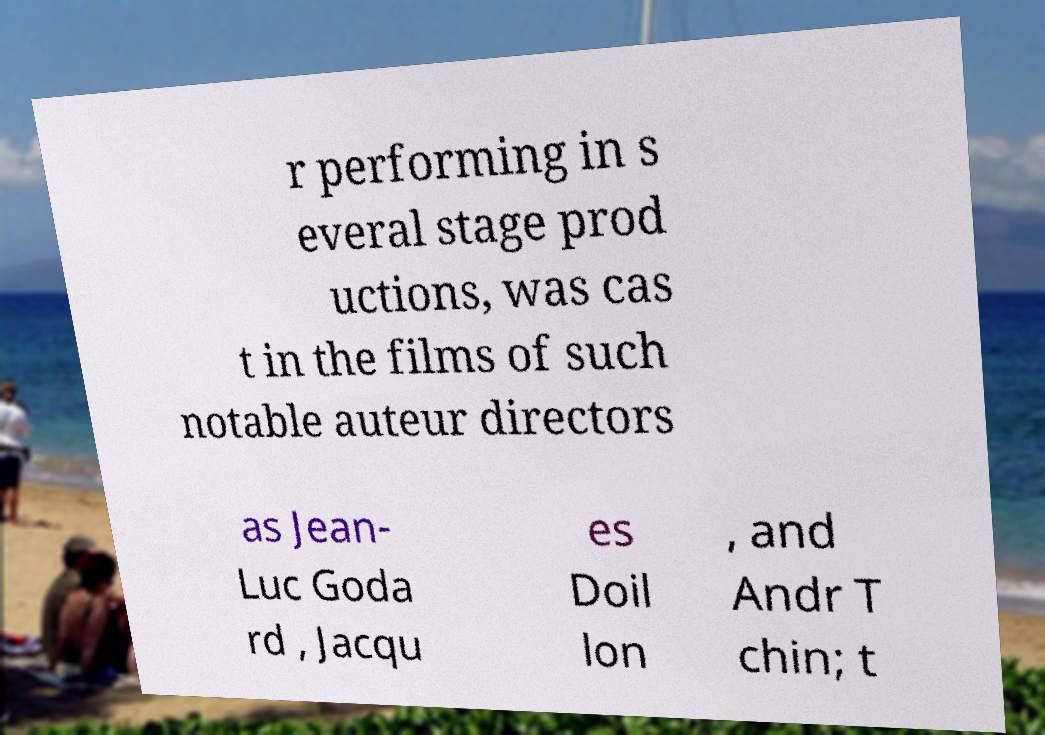Could you extract and type out the text from this image? r performing in s everal stage prod uctions, was cas t in the films of such notable auteur directors as Jean- Luc Goda rd , Jacqu es Doil lon , and Andr T chin; t 